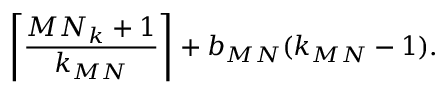<formula> <loc_0><loc_0><loc_500><loc_500>\left \lceil \frac { M N _ { k } + 1 } { k _ { M N } } \right \rceil + b _ { M N } ( k _ { M N } - 1 ) .</formula> 